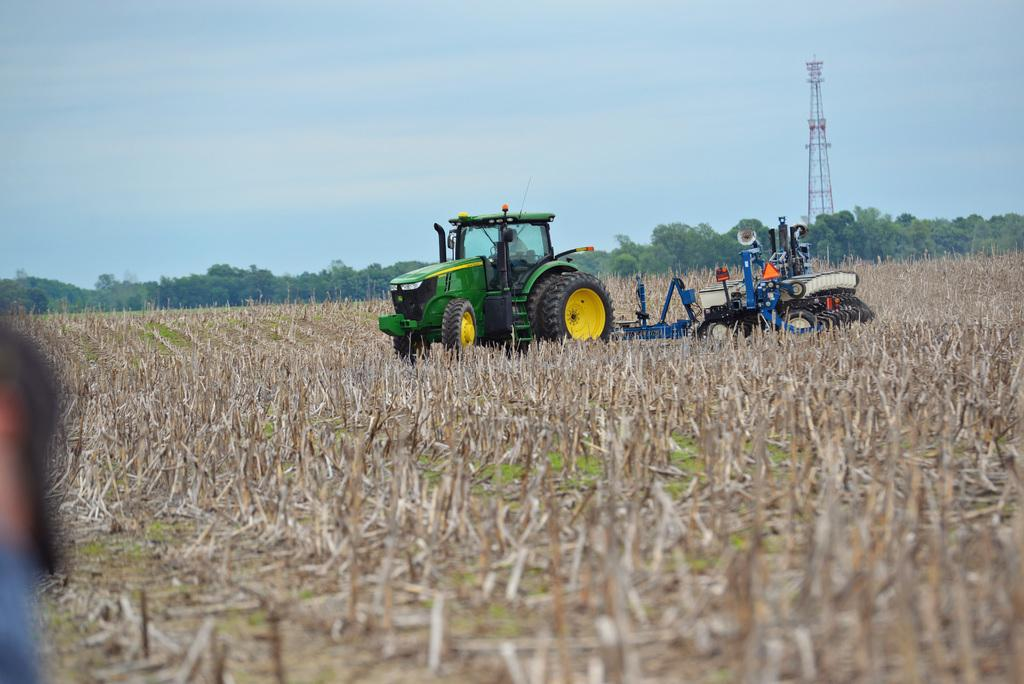What type of vehicles are present in the image? There is a tractor and a bulldozer in the image. Where are the tractor and bulldozer located? They are located in an agricultural farm. What can be seen in the background of the image? There is sky, clouds, a tower, and trees visible in the background of the image. What type of account is being discussed in the image? There is no account being discussed in the image; it features a tractor and a bulldozer in an agricultural farm. Are there any bears visible in the image? No, there are no bears present in the image. 